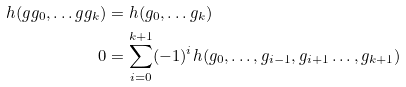<formula> <loc_0><loc_0><loc_500><loc_500>h ( g g _ { 0 } , \dots g g _ { k } ) & = h ( g _ { 0 } , \dots g _ { k } ) \\ 0 & = \sum _ { i = 0 } ^ { k + 1 } ( - 1 ) ^ { i } h ( g _ { 0 } , \dots , g _ { i - 1 } , g _ { i + 1 } \dots , g _ { k + 1 } )</formula> 